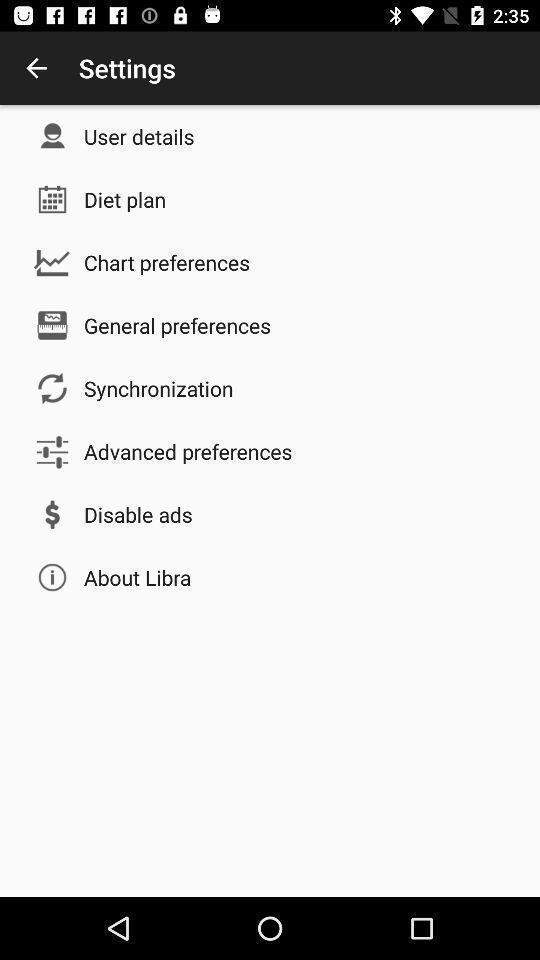What details can you identify in this image? Settings page with multiple options. 